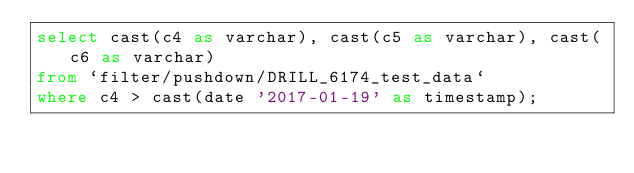Convert code to text. <code><loc_0><loc_0><loc_500><loc_500><_SQL_>select cast(c4 as varchar), cast(c5 as varchar), cast(c6 as varchar)
from `filter/pushdown/DRILL_6174_test_data`
where c4 > cast(date '2017-01-19' as timestamp);</code> 